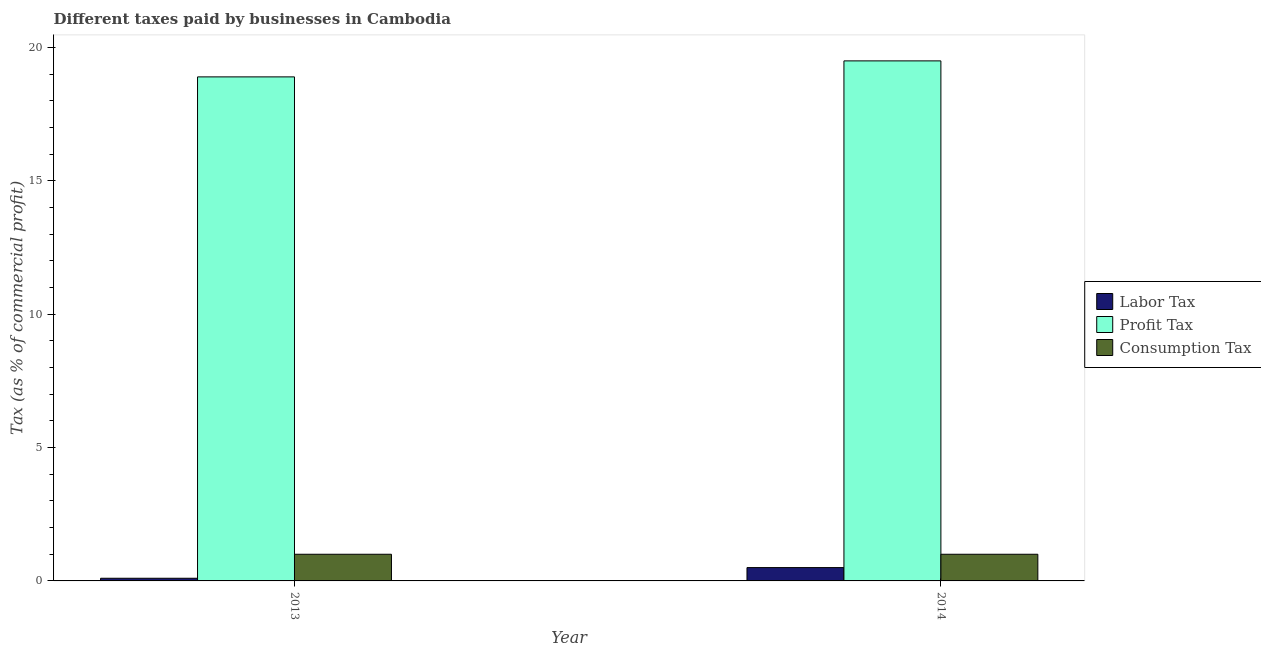Are the number of bars per tick equal to the number of legend labels?
Your answer should be compact. Yes. Are the number of bars on each tick of the X-axis equal?
Offer a terse response. Yes. What is the label of the 1st group of bars from the left?
Keep it short and to the point. 2013. In how many cases, is the number of bars for a given year not equal to the number of legend labels?
Offer a very short reply. 0. What is the percentage of labor tax in 2014?
Offer a very short reply. 0.5. Across all years, what is the maximum percentage of labor tax?
Your response must be concise. 0.5. Across all years, what is the minimum percentage of labor tax?
Offer a very short reply. 0.1. What is the total percentage of consumption tax in the graph?
Make the answer very short. 2. What is the difference between the percentage of labor tax in 2013 and the percentage of profit tax in 2014?
Provide a succinct answer. -0.4. What is the average percentage of consumption tax per year?
Provide a short and direct response. 1. In the year 2013, what is the difference between the percentage of profit tax and percentage of labor tax?
Keep it short and to the point. 0. In how many years, is the percentage of labor tax greater than 10 %?
Your response must be concise. 0. What is the ratio of the percentage of consumption tax in 2013 to that in 2014?
Provide a short and direct response. 1. What does the 1st bar from the left in 2013 represents?
Provide a succinct answer. Labor Tax. What does the 1st bar from the right in 2014 represents?
Ensure brevity in your answer.  Consumption Tax. Is it the case that in every year, the sum of the percentage of labor tax and percentage of profit tax is greater than the percentage of consumption tax?
Your answer should be compact. Yes. How many bars are there?
Provide a succinct answer. 6. How many years are there in the graph?
Offer a very short reply. 2. What is the difference between two consecutive major ticks on the Y-axis?
Your answer should be compact. 5. Does the graph contain any zero values?
Offer a terse response. No. Where does the legend appear in the graph?
Offer a very short reply. Center right. What is the title of the graph?
Give a very brief answer. Different taxes paid by businesses in Cambodia. What is the label or title of the X-axis?
Your answer should be compact. Year. What is the label or title of the Y-axis?
Ensure brevity in your answer.  Tax (as % of commercial profit). What is the Tax (as % of commercial profit) of Labor Tax in 2013?
Provide a succinct answer. 0.1. What is the Tax (as % of commercial profit) of Consumption Tax in 2013?
Your answer should be compact. 1. What is the Tax (as % of commercial profit) in Labor Tax in 2014?
Your response must be concise. 0.5. What is the Tax (as % of commercial profit) of Profit Tax in 2014?
Your answer should be very brief. 19.5. What is the Tax (as % of commercial profit) of Consumption Tax in 2014?
Provide a succinct answer. 1. Across all years, what is the maximum Tax (as % of commercial profit) of Labor Tax?
Provide a short and direct response. 0.5. Across all years, what is the maximum Tax (as % of commercial profit) in Profit Tax?
Offer a terse response. 19.5. Across all years, what is the maximum Tax (as % of commercial profit) in Consumption Tax?
Offer a very short reply. 1. Across all years, what is the minimum Tax (as % of commercial profit) in Consumption Tax?
Provide a succinct answer. 1. What is the total Tax (as % of commercial profit) of Labor Tax in the graph?
Give a very brief answer. 0.6. What is the total Tax (as % of commercial profit) in Profit Tax in the graph?
Keep it short and to the point. 38.4. What is the total Tax (as % of commercial profit) in Consumption Tax in the graph?
Make the answer very short. 2. What is the difference between the Tax (as % of commercial profit) in Profit Tax in 2013 and that in 2014?
Provide a succinct answer. -0.6. What is the difference between the Tax (as % of commercial profit) of Labor Tax in 2013 and the Tax (as % of commercial profit) of Profit Tax in 2014?
Provide a short and direct response. -19.4. What is the difference between the Tax (as % of commercial profit) of Labor Tax in 2013 and the Tax (as % of commercial profit) of Consumption Tax in 2014?
Provide a succinct answer. -0.9. What is the difference between the Tax (as % of commercial profit) of Profit Tax in 2013 and the Tax (as % of commercial profit) of Consumption Tax in 2014?
Provide a short and direct response. 17.9. What is the average Tax (as % of commercial profit) of Labor Tax per year?
Make the answer very short. 0.3. What is the average Tax (as % of commercial profit) of Profit Tax per year?
Make the answer very short. 19.2. In the year 2013, what is the difference between the Tax (as % of commercial profit) of Labor Tax and Tax (as % of commercial profit) of Profit Tax?
Keep it short and to the point. -18.8. In the year 2013, what is the difference between the Tax (as % of commercial profit) in Labor Tax and Tax (as % of commercial profit) in Consumption Tax?
Make the answer very short. -0.9. In the year 2014, what is the difference between the Tax (as % of commercial profit) in Labor Tax and Tax (as % of commercial profit) in Profit Tax?
Ensure brevity in your answer.  -19. What is the ratio of the Tax (as % of commercial profit) in Labor Tax in 2013 to that in 2014?
Your response must be concise. 0.2. What is the ratio of the Tax (as % of commercial profit) in Profit Tax in 2013 to that in 2014?
Provide a succinct answer. 0.97. What is the difference between the highest and the second highest Tax (as % of commercial profit) in Profit Tax?
Provide a short and direct response. 0.6. What is the difference between the highest and the second highest Tax (as % of commercial profit) in Consumption Tax?
Make the answer very short. 0. What is the difference between the highest and the lowest Tax (as % of commercial profit) of Consumption Tax?
Ensure brevity in your answer.  0. 